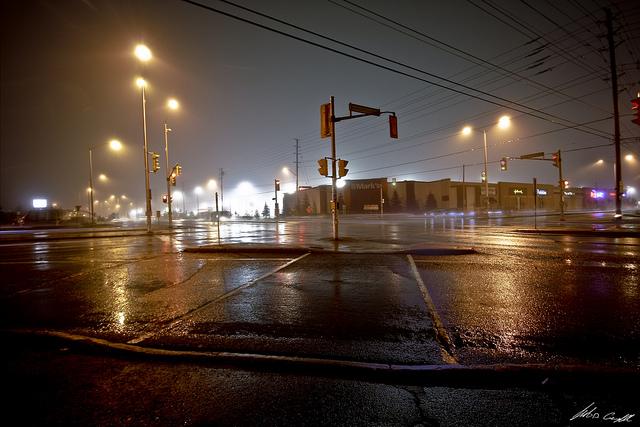How many street lights are in this image?
Answer briefly. Many. Are there many cars on the street?
Write a very short answer. No. Why are the lights so bright?
Concise answer only. Fog. Are there any streetlights facing the camera?
Keep it brief. Yes. Is this a day or night scene?
Short answer required. Night. How many overhead signal lights are on?
Be succinct. 0. Did it rain some time during the day or night?
Short answer required. Yes. How many street lamps are there?
Give a very brief answer. 6. 